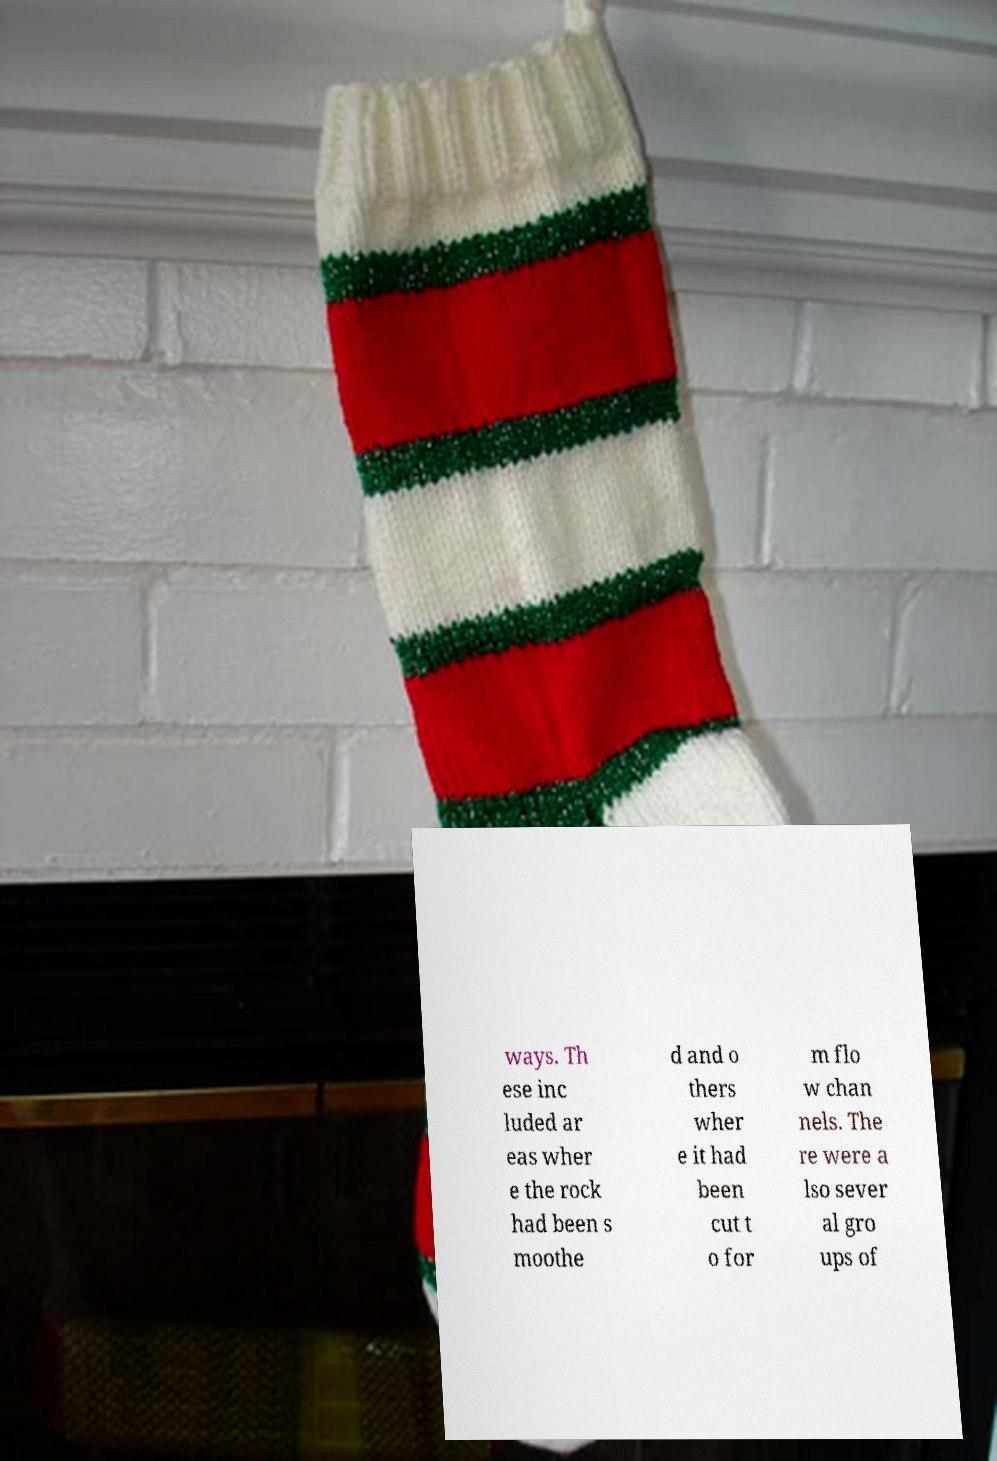Please read and relay the text visible in this image. What does it say? ways. Th ese inc luded ar eas wher e the rock had been s moothe d and o thers wher e it had been cut t o for m flo w chan nels. The re were a lso sever al gro ups of 